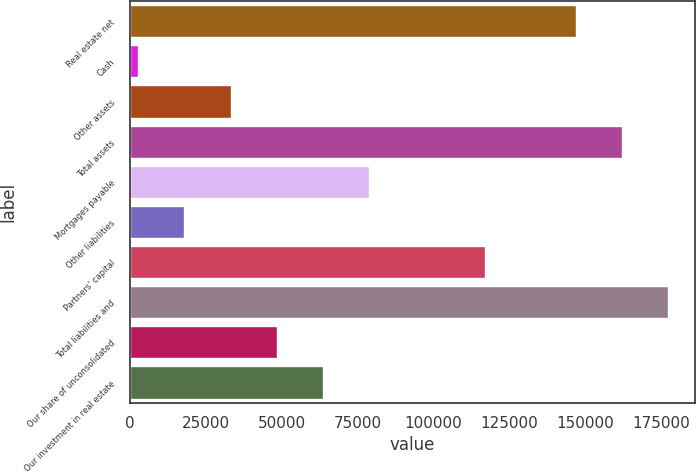<chart> <loc_0><loc_0><loc_500><loc_500><bar_chart><fcel>Real estate net<fcel>Cash<fcel>Other assets<fcel>Total assets<fcel>Mortgages payable<fcel>Other liabilities<fcel>Partners' capital<fcel>Total liabilities and<fcel>Our share of unconsolidated<fcel>Our investment in real estate<nl><fcel>146906<fcel>2690<fcel>33170.2<fcel>162146<fcel>78890.5<fcel>17930.1<fcel>117152<fcel>177386<fcel>48410.3<fcel>63650.4<nl></chart> 